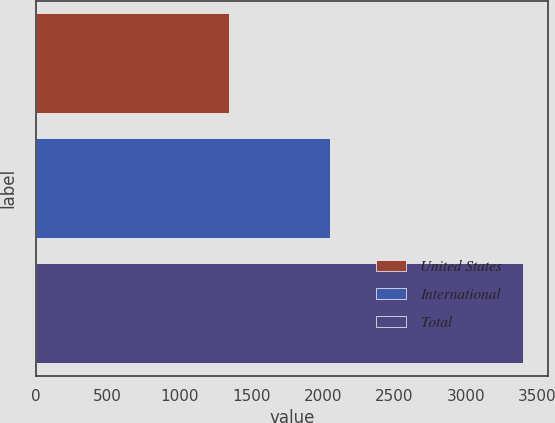Convert chart to OTSL. <chart><loc_0><loc_0><loc_500><loc_500><bar_chart><fcel>United States<fcel>International<fcel>Total<nl><fcel>1346.5<fcel>2054.2<fcel>3400.7<nl></chart> 